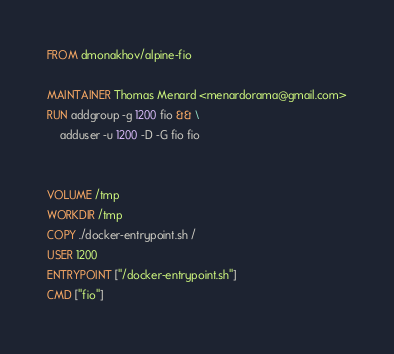Convert code to text. <code><loc_0><loc_0><loc_500><loc_500><_Dockerfile_>FROM dmonakhov/alpine-fio

MAINTAINER Thomas Menard <menardorama@gmail.com>
RUN addgroup -g 1200 fio && \
    adduser -u 1200 -D -G fio fio


VOLUME /tmp
WORKDIR /tmp
COPY ./docker-entrypoint.sh /
USER 1200
ENTRYPOINT ["/docker-entrypoint.sh"]
CMD ["fio"]
</code> 